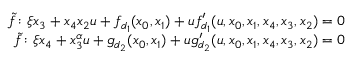<formula> <loc_0><loc_0><loc_500><loc_500>\begin{array} { r } { \widetilde { f } \colon \xi x _ { 3 } + x _ { 4 } x _ { 2 } u + f _ { d _ { 1 } } ( x _ { 0 } , x _ { 1 } ) + u f _ { d _ { 1 } } ^ { \prime } ( u , x _ { 0 } , x _ { 1 } , x _ { 4 } , x _ { 3 } , x _ { 2 } ) = 0 } \\ { \widetilde { f } \colon \xi x _ { 4 } + x _ { 3 } ^ { \alpha } u + g _ { d _ { 2 } } ( x _ { 0 } , x _ { 1 } ) + u g _ { d _ { 2 } } ^ { \prime } ( u , x _ { 0 } , x _ { 1 } , x _ { 4 } , x _ { 3 } , x _ { 2 } ) = 0 } \end{array}</formula> 